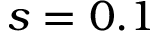Convert formula to latex. <formula><loc_0><loc_0><loc_500><loc_500>s = 0 . 1</formula> 